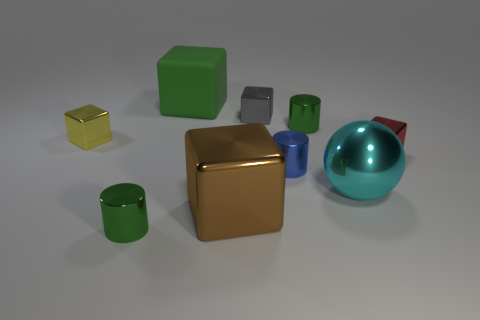Is there anything else that is made of the same material as the large green block?
Provide a short and direct response. No. What number of small gray cubes are on the right side of the small green cylinder that is in front of the cube that is left of the big rubber thing?
Give a very brief answer. 1. Do the metal object that is in front of the brown shiny cube and the large cyan metallic thing have the same shape?
Give a very brief answer. No. There is a green cylinder that is on the left side of the large rubber object; are there any green objects that are to the left of it?
Provide a short and direct response. No. How many shiny objects are there?
Ensure brevity in your answer.  8. There is a metal thing that is on the right side of the small blue shiny cylinder and behind the small red object; what color is it?
Provide a short and direct response. Green. What is the size of the brown metal object that is the same shape as the big rubber object?
Give a very brief answer. Large. How many other shiny things are the same size as the gray object?
Ensure brevity in your answer.  5. What material is the gray cube?
Ensure brevity in your answer.  Metal. There is a small gray object; are there any blue metal cylinders left of it?
Your response must be concise. No. 